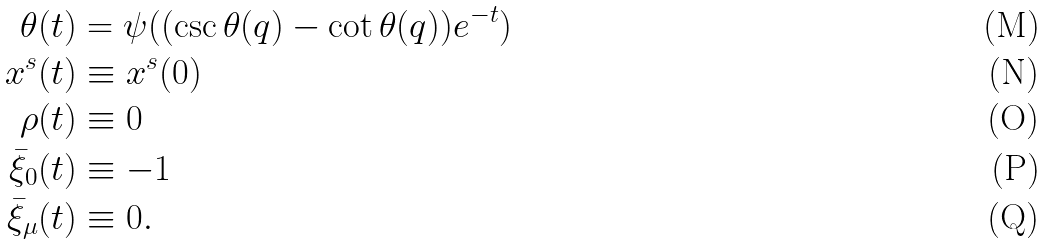Convert formula to latex. <formula><loc_0><loc_0><loc_500><loc_500>\theta ( t ) & = \psi ( ( \csc \theta ( q ) - \cot \theta ( q ) ) e ^ { - t } ) \\ x ^ { s } ( t ) & \equiv x ^ { s } ( 0 ) \\ \rho ( t ) & \equiv 0 \\ \bar { \xi } _ { 0 } ( t ) & \equiv - 1 \\ \bar { \xi } _ { \mu } ( t ) & \equiv 0 .</formula> 